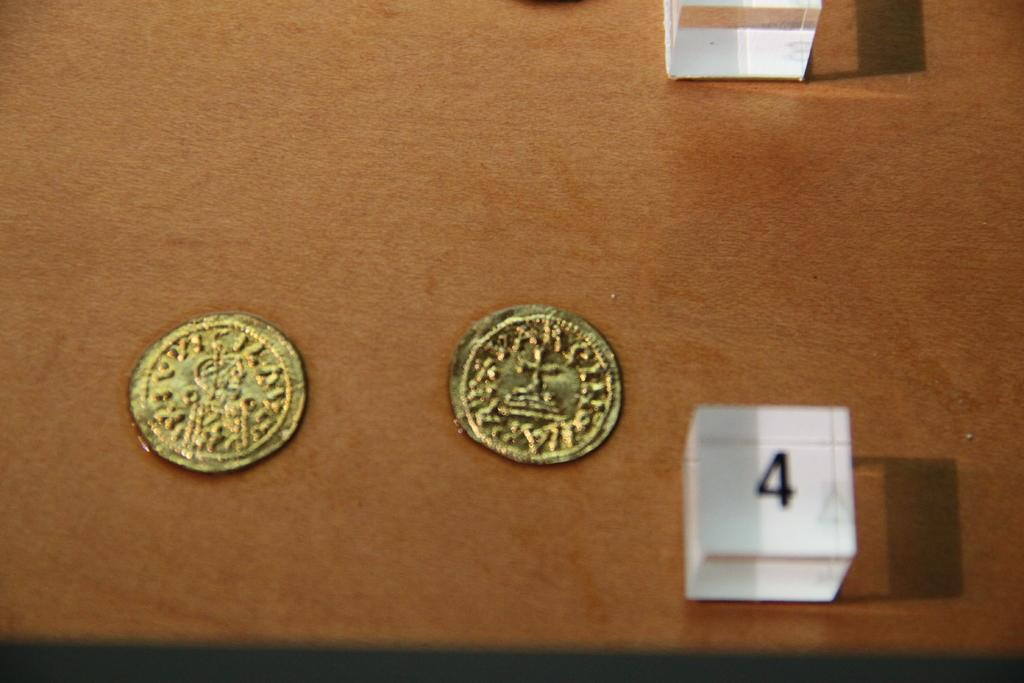<image>
Create a compact narrative representing the image presented. A white cube with the number four next to two gold coins. 